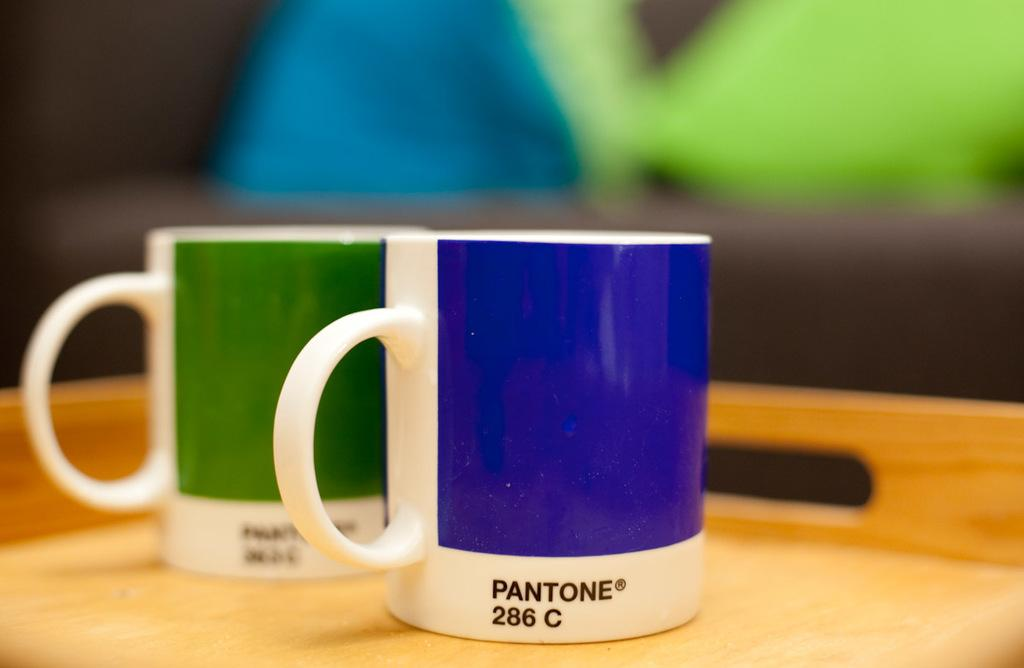<image>
Offer a succinct explanation of the picture presented. Two coffee mugs, one with a green block of color, one with a blue block that reads Pantone 286 C. 